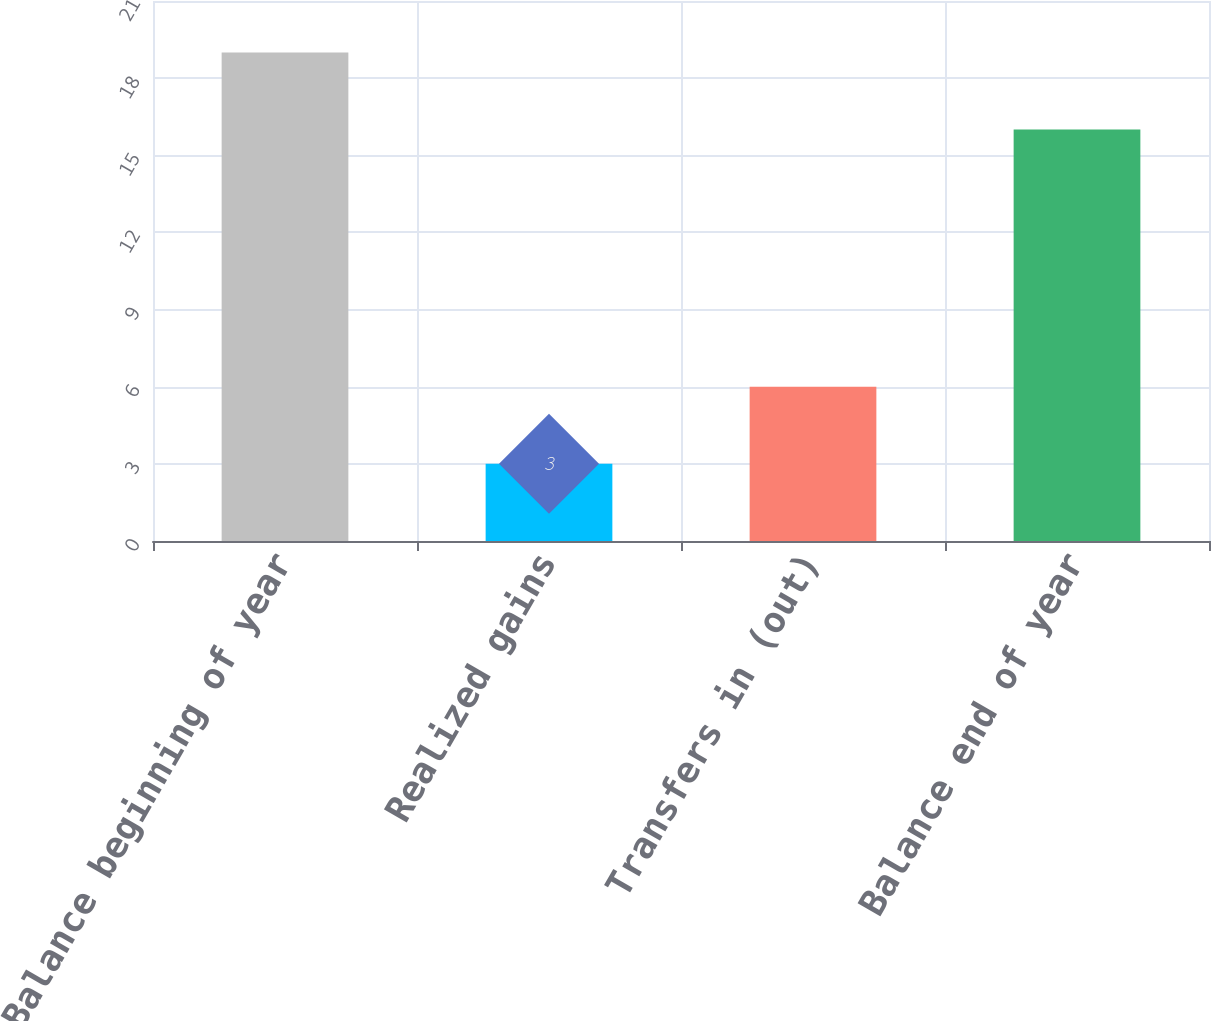<chart> <loc_0><loc_0><loc_500><loc_500><bar_chart><fcel>Balance beginning of year<fcel>Realized gains<fcel>Transfers in (out)<fcel>Balance end of year<nl><fcel>19<fcel>3<fcel>6<fcel>16<nl></chart> 